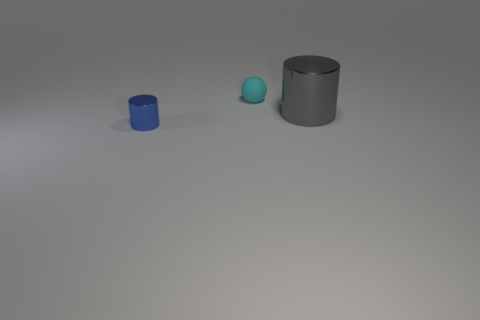Add 1 purple metallic blocks. How many objects exist? 4 Subtract all balls. How many objects are left? 2 Subtract all big gray rubber cubes. Subtract all small blue shiny things. How many objects are left? 2 Add 3 gray objects. How many gray objects are left? 4 Add 3 gray matte balls. How many gray matte balls exist? 3 Subtract 0 green spheres. How many objects are left? 3 